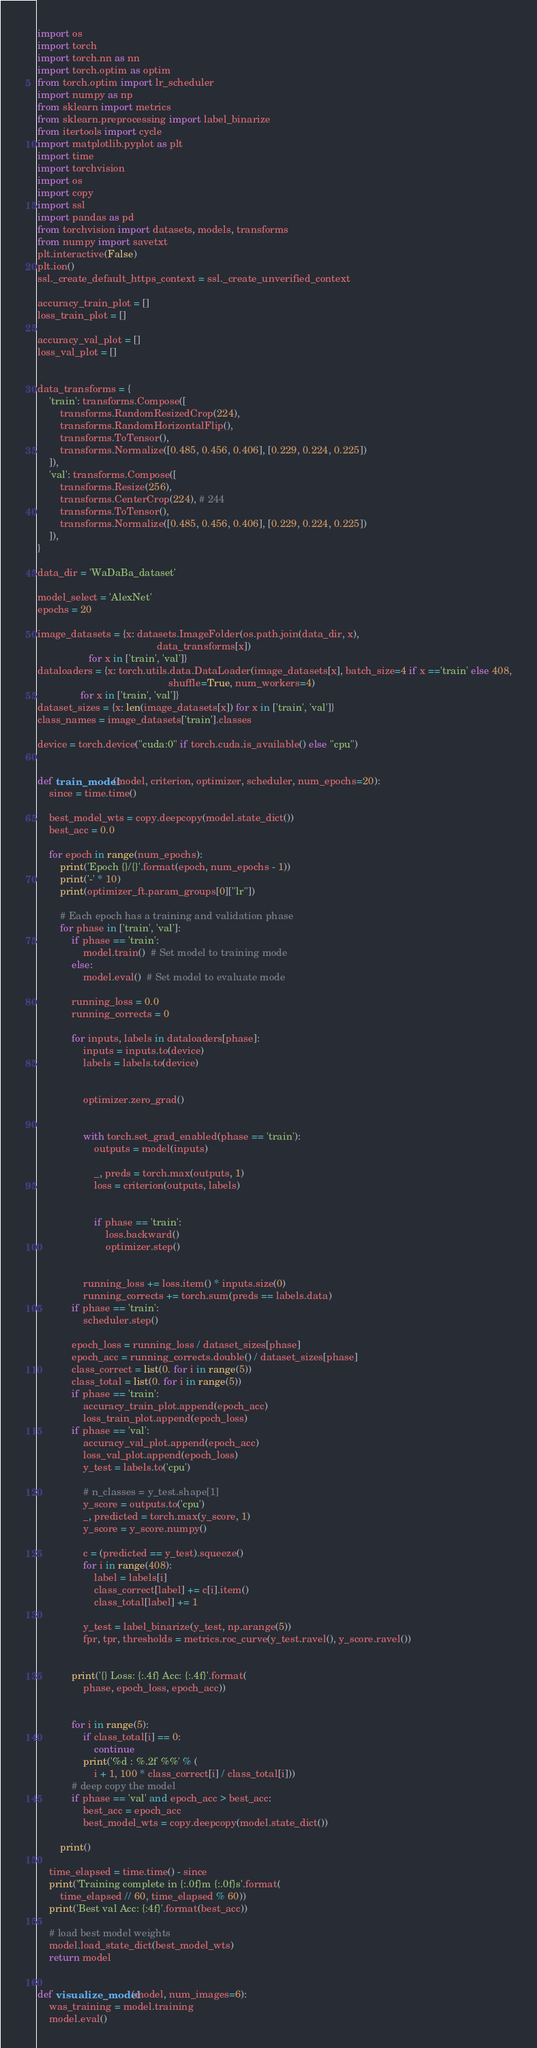Convert code to text. <code><loc_0><loc_0><loc_500><loc_500><_Python_>import os
import torch
import torch.nn as nn
import torch.optim as optim
from torch.optim import lr_scheduler
import numpy as np
from sklearn import metrics
from sklearn.preprocessing import label_binarize
from itertools import cycle
import matplotlib.pyplot as plt
import time
import torchvision
import os
import copy
import ssl
import pandas as pd
from torchvision import datasets, models, transforms
from numpy import savetxt
plt.interactive(False)
plt.ion() 
ssl._create_default_https_context = ssl._create_unverified_context

accuracy_train_plot = []
loss_train_plot = []

accuracy_val_plot = []
loss_val_plot = []


data_transforms = {
    'train': transforms.Compose([
        transforms.RandomResizedCrop(224),
        transforms.RandomHorizontalFlip(),
        transforms.ToTensor(),
        transforms.Normalize([0.485, 0.456, 0.406], [0.229, 0.224, 0.225])
    ]),
    'val': transforms.Compose([
        transforms.Resize(256),
        transforms.CenterCrop(224), # 244
        transforms.ToTensor(),
        transforms.Normalize([0.485, 0.456, 0.406], [0.229, 0.224, 0.225])
    ]),
}

data_dir = 'WaDaBa_dataset'

model_select = 'AlexNet'
epochs = 20

image_datasets = {x: datasets.ImageFolder(os.path.join(data_dir, x),
                                          data_transforms[x])
                  for x in ['train', 'val']}
dataloaders = {x: torch.utils.data.DataLoader(image_datasets[x], batch_size=4 if x =='train' else 408,
                                              shuffle=True, num_workers=4)
               for x in ['train', 'val']}
dataset_sizes = {x: len(image_datasets[x]) for x in ['train', 'val']}
class_names = image_datasets['train'].classes

device = torch.device("cuda:0" if torch.cuda.is_available() else "cpu")


def train_model(model, criterion, optimizer, scheduler, num_epochs=20):
    since = time.time()

    best_model_wts = copy.deepcopy(model.state_dict())
    best_acc = 0.0

    for epoch in range(num_epochs):
        print('Epoch {}/{}'.format(epoch, num_epochs - 1))
        print('-' * 10)
        print(optimizer_ft.param_groups[0]["lr"])

        # Each epoch has a training and validation phase
        for phase in ['train', 'val']:
            if phase == 'train':
                model.train()  # Set model to training mode
            else:
                model.eval()  # Set model to evaluate mode

            running_loss = 0.0
            running_corrects = 0

            for inputs, labels in dataloaders[phase]:
                inputs = inputs.to(device)
                labels = labels.to(device)

                
                optimizer.zero_grad()

               
                with torch.set_grad_enabled(phase == 'train'):
                    outputs = model(inputs)

                    _, preds = torch.max(outputs, 1)
                    loss = criterion(outputs, labels)

                    
                    if phase == 'train':
                        loss.backward()
                        optimizer.step()

             
                running_loss += loss.item() * inputs.size(0)
                running_corrects += torch.sum(preds == labels.data)
            if phase == 'train':
                scheduler.step()

            epoch_loss = running_loss / dataset_sizes[phase]
            epoch_acc = running_corrects.double() / dataset_sizes[phase]
            class_correct = list(0. for i in range(5))
            class_total = list(0. for i in range(5))
            if phase == 'train':
                accuracy_train_plot.append(epoch_acc)
                loss_train_plot.append(epoch_loss)
            if phase == 'val':
                accuracy_val_plot.append(epoch_acc)
                loss_val_plot.append(epoch_loss)
                y_test = labels.to('cpu')

                # n_classes = y_test.shape[1]
                y_score = outputs.to('cpu')
                _, predicted = torch.max(y_score, 1)
                y_score = y_score.numpy()

                c = (predicted == y_test).squeeze()
                for i in range(408):
                    label = labels[i]
                    class_correct[label] += c[i].item()
                    class_total[label] += 1

                y_test = label_binarize(y_test, np.arange(5))
                fpr, tpr, thresholds = metrics.roc_curve(y_test.ravel(), y_score.ravel())


            print('{} Loss: {:.4f} Acc: {:.4f}'.format(
                phase, epoch_loss, epoch_acc))


            for i in range(5):
                if class_total[i] == 0:
                    continue
                print('%d : %.2f %%' % (
                    i + 1, 100 * class_correct[i] / class_total[i]))
            # deep copy the model
            if phase == 'val' and epoch_acc > best_acc:
                best_acc = epoch_acc
                best_model_wts = copy.deepcopy(model.state_dict())

        print()

    time_elapsed = time.time() - since
    print('Training complete in {:.0f}m {:.0f}s'.format(
        time_elapsed // 60, time_elapsed % 60))
    print('Best val Acc: {:4f}'.format(best_acc))

    # load best model weights
    model.load_state_dict(best_model_wts)
    return model


def visualize_model(model, num_images=6):
    was_training = model.training
    model.eval()</code> 